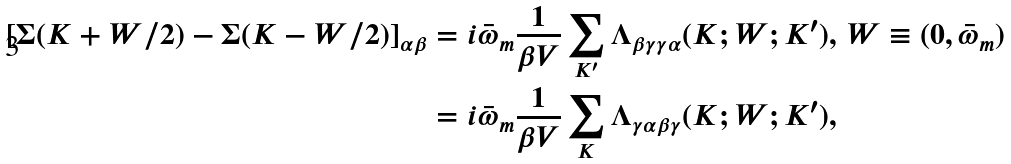<formula> <loc_0><loc_0><loc_500><loc_500>[ \Sigma ( K + W / 2 ) - \Sigma ( K - W / 2 ) ] _ { \alpha \beta } & = i \bar { \omega } _ { m } \frac { 1 } { \beta V } \sum _ { K ^ { \prime } } { \Lambda } _ { \beta \gamma \gamma \alpha } ( K ; W ; K ^ { \prime } ) , \, W \equiv ( 0 , \bar { \omega } _ { m } ) \\ & = i \bar { \omega } _ { m } \frac { 1 } { \beta V } \sum _ { K } { \Lambda } _ { \gamma \alpha \beta \gamma } ( K ; W ; K ^ { \prime } ) ,</formula> 